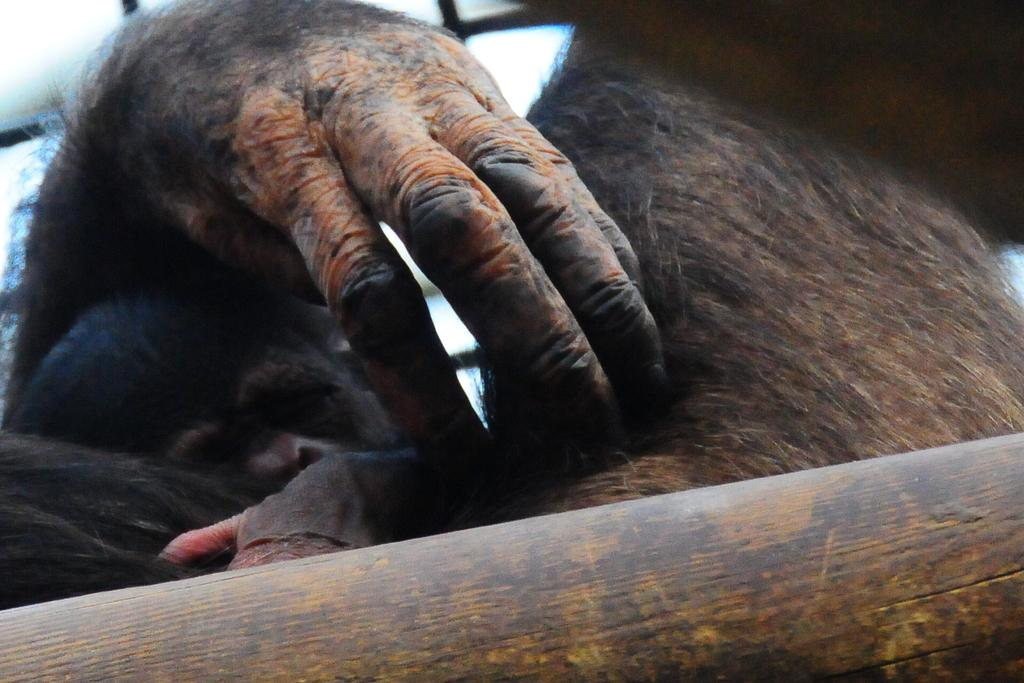How many animals are present in the image? There are two animals in the image. Can you describe the wooden object in the image? Unfortunately, the facts provided do not give any details about the wooden object. However, we can confirm that there is a wooden object present in the image. How does the breath of the animals affect the plough in the image? There is no plough present in the image, so it is not possible to answer this question. 